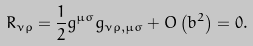<formula> <loc_0><loc_0><loc_500><loc_500>R _ { \nu \rho } = \frac { 1 } { 2 } g ^ { \mu \sigma } g _ { \nu \rho , \mu \sigma } + O \left ( b ^ { 2 } \right ) = 0 .</formula> 